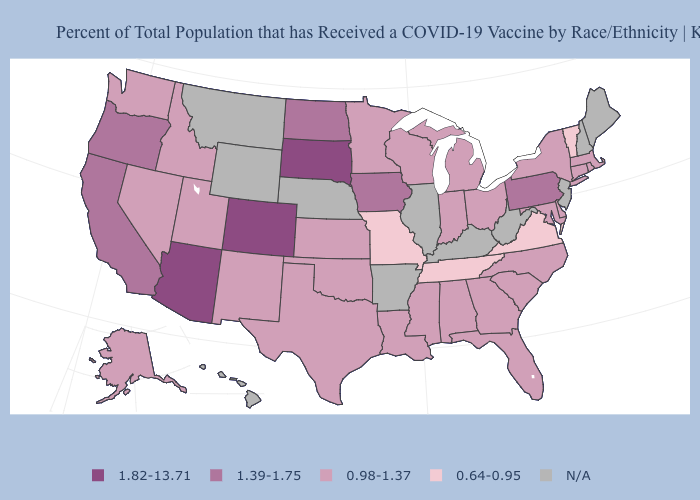Among the states that border Mississippi , which have the lowest value?
Concise answer only. Tennessee. What is the value of New Hampshire?
Write a very short answer. N/A. Does Virginia have the lowest value in the USA?
Quick response, please. Yes. What is the value of Utah?
Concise answer only. 0.98-1.37. What is the value of North Carolina?
Be succinct. 0.98-1.37. Is the legend a continuous bar?
Write a very short answer. No. Which states have the highest value in the USA?
Be succinct. Arizona, Colorado, South Dakota. What is the highest value in the USA?
Quick response, please. 1.82-13.71. Which states have the lowest value in the USA?
Short answer required. Missouri, Tennessee, Vermont, Virginia. Which states have the lowest value in the USA?
Answer briefly. Missouri, Tennessee, Vermont, Virginia. Which states hav the highest value in the Northeast?
Give a very brief answer. Pennsylvania. Name the states that have a value in the range 1.39-1.75?
Concise answer only. California, Iowa, North Dakota, Oregon, Pennsylvania. 